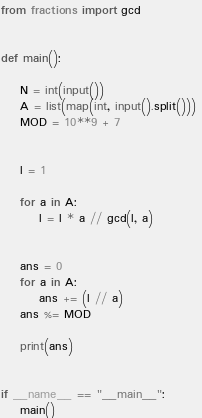<code> <loc_0><loc_0><loc_500><loc_500><_Python_>from fractions import gcd


def main():
        
    N = int(input())
    A = list(map(int, input().split())) 
    MOD = 10**9 + 7


    l = 1

    for a in A:
        l = l * a // gcd(l, a)


    ans = 0
    for a in A:
        ans += (l // a)
    ans %= MOD

    print(ans)


if __name__ == "__main__":
    main()</code> 